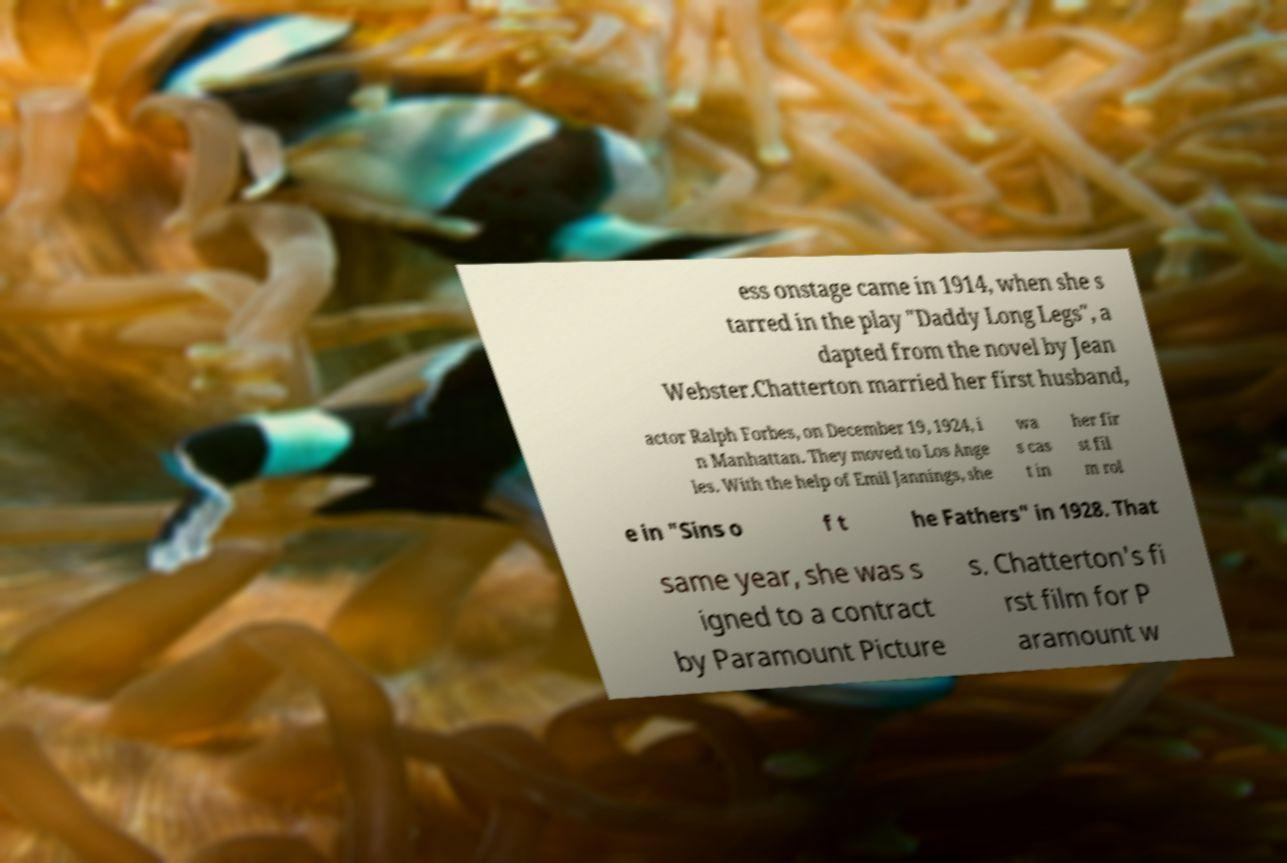What messages or text are displayed in this image? I need them in a readable, typed format. ess onstage came in 1914, when she s tarred in the play "Daddy Long Legs", a dapted from the novel by Jean Webster.Chatterton married her first husband, actor Ralph Forbes, on December 19, 1924, i n Manhattan. They moved to Los Ange les. With the help of Emil Jannings, she wa s cas t in her fir st fil m rol e in "Sins o f t he Fathers" in 1928. That same year, she was s igned to a contract by Paramount Picture s. Chatterton's fi rst film for P aramount w 